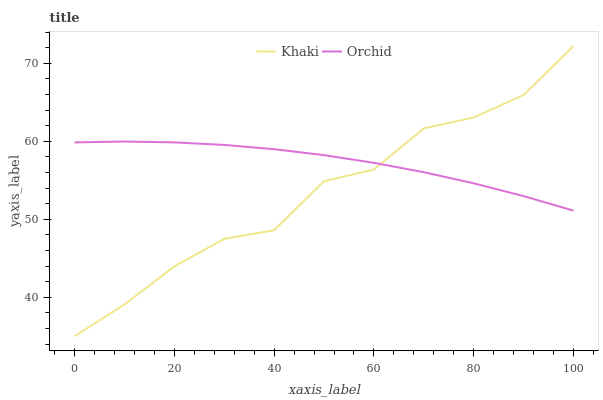Does Khaki have the minimum area under the curve?
Answer yes or no. Yes. Does Orchid have the maximum area under the curve?
Answer yes or no. Yes. Does Orchid have the minimum area under the curve?
Answer yes or no. No. Is Orchid the smoothest?
Answer yes or no. Yes. Is Khaki the roughest?
Answer yes or no. Yes. Is Orchid the roughest?
Answer yes or no. No. Does Orchid have the lowest value?
Answer yes or no. No. Does Khaki have the highest value?
Answer yes or no. Yes. Does Orchid have the highest value?
Answer yes or no. No. 